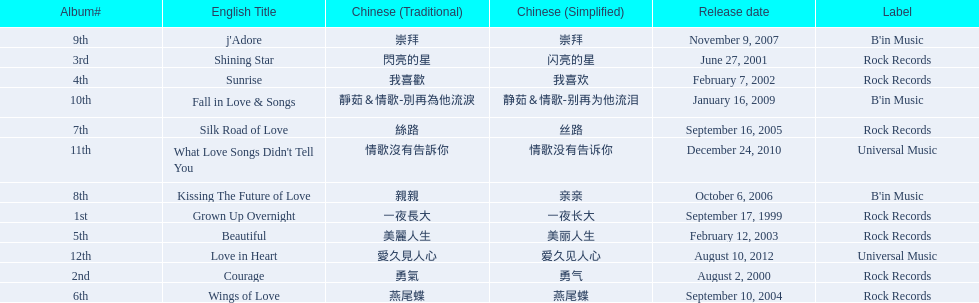Which english titles were released during even years? Courage, Sunrise, Silk Road of Love, Kissing The Future of Love, What Love Songs Didn't Tell You, Love in Heart. Parse the full table. {'header': ['Album#', 'English Title', 'Chinese (Traditional)', 'Chinese (Simplified)', 'Release date', 'Label'], 'rows': [['9th', "j'Adore", '崇拜', '崇拜', 'November 9, 2007', "B'in Music"], ['3rd', 'Shining Star', '閃亮的星', '闪亮的星', 'June 27, 2001', 'Rock Records'], ['4th', 'Sunrise', '我喜歡', '我喜欢', 'February 7, 2002', 'Rock Records'], ['10th', 'Fall in Love & Songs', '靜茹＆情歌-別再為他流淚', '静茹＆情歌-别再为他流泪', 'January 16, 2009', "B'in Music"], ['7th', 'Silk Road of Love', '絲路', '丝路', 'September 16, 2005', 'Rock Records'], ['11th', "What Love Songs Didn't Tell You", '情歌沒有告訴你', '情歌没有告诉你', 'December 24, 2010', 'Universal Music'], ['8th', 'Kissing The Future of Love', '親親', '亲亲', 'October 6, 2006', "B'in Music"], ['1st', 'Grown Up Overnight', '一夜長大', '一夜长大', 'September 17, 1999', 'Rock Records'], ['5th', 'Beautiful', '美麗人生', '美丽人生', 'February 12, 2003', 'Rock Records'], ['12th', 'Love in Heart', '愛久見人心', '爱久见人心', 'August 10, 2012', 'Universal Music'], ['2nd', 'Courage', '勇氣', '勇气', 'August 2, 2000', 'Rock Records'], ['6th', 'Wings of Love', '燕尾蝶', '燕尾蝶', 'September 10, 2004', 'Rock Records']]} Out of the following, which one was released under b's in music? Kissing The Future of Love. 